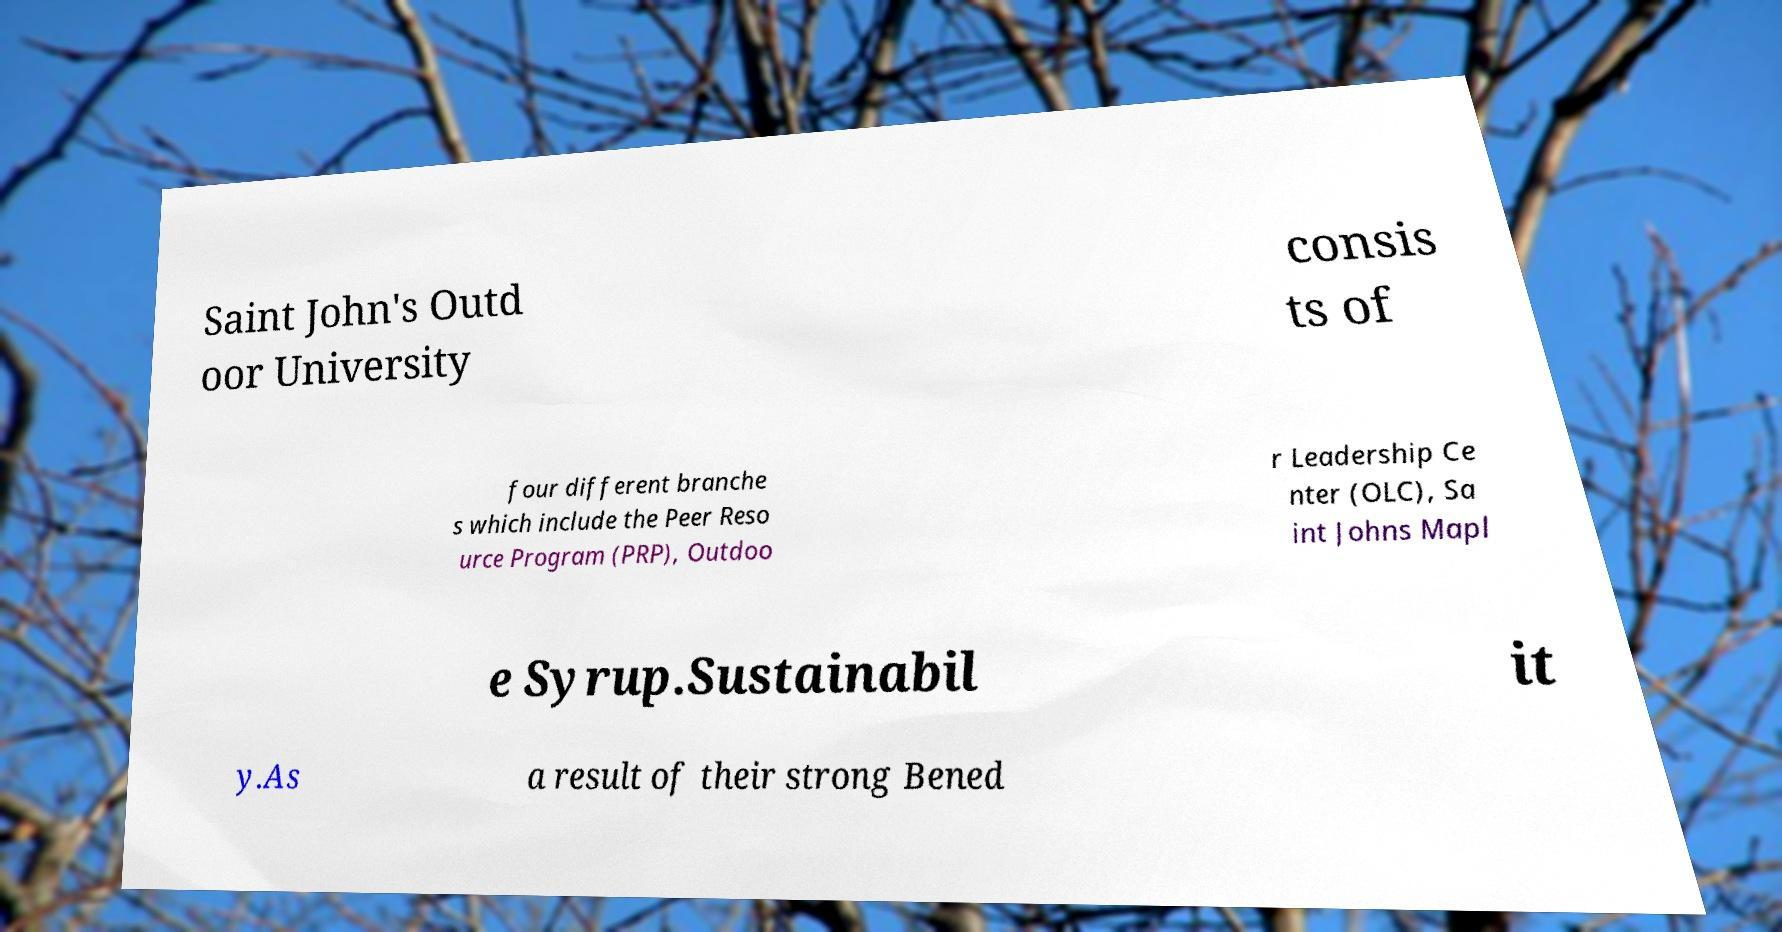Can you read and provide the text displayed in the image?This photo seems to have some interesting text. Can you extract and type it out for me? Saint John's Outd oor University consis ts of four different branche s which include the Peer Reso urce Program (PRP), Outdoo r Leadership Ce nter (OLC), Sa int Johns Mapl e Syrup.Sustainabil it y.As a result of their strong Bened 